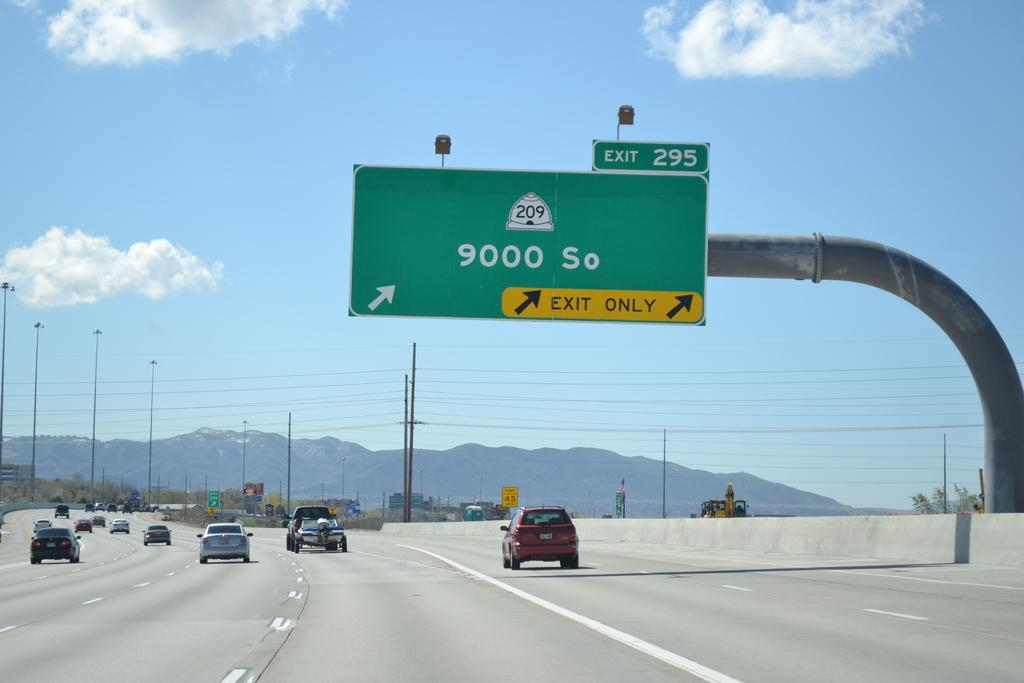<image>
Describe the image concisely. Green highway sign which say the exit is 295. 